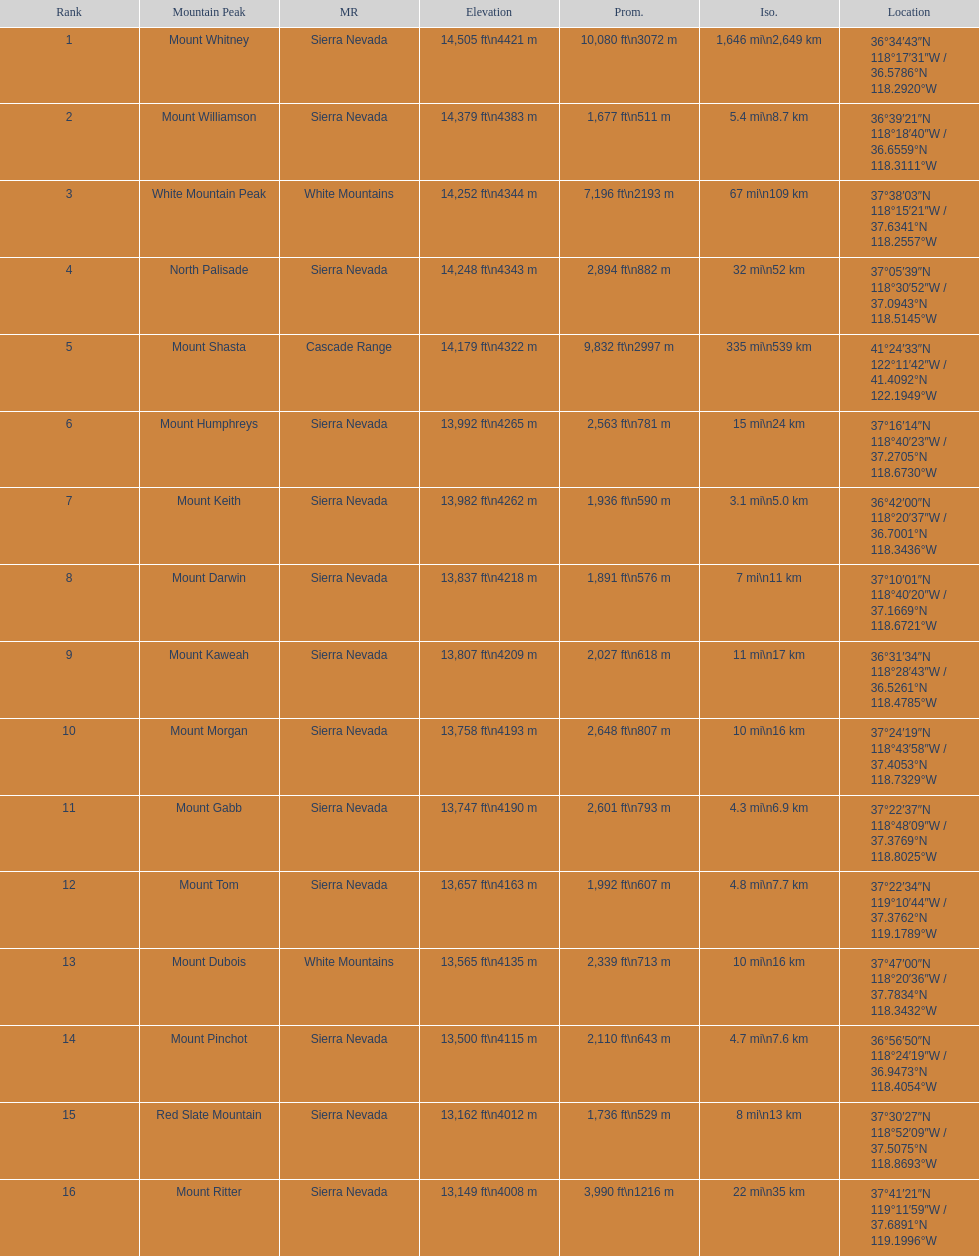Which mountain peak has the most isolation? Mount Whitney. 